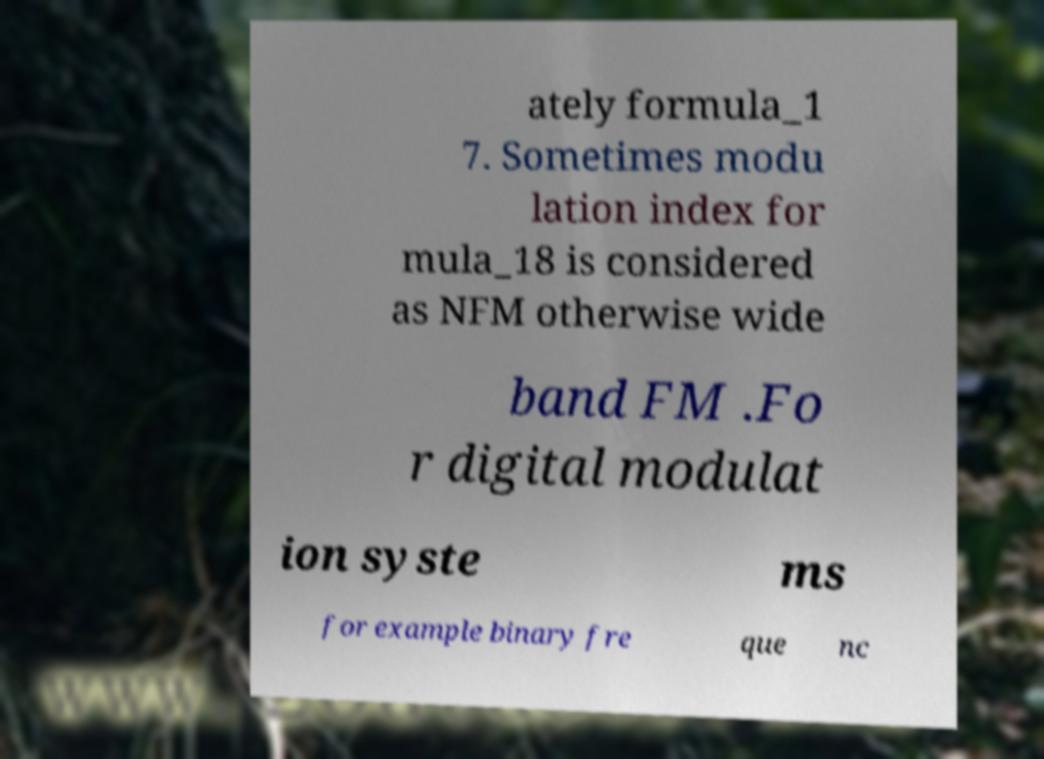Could you extract and type out the text from this image? ately formula_1 7. Sometimes modu lation index for mula_18 is considered as NFM otherwise wide band FM .Fo r digital modulat ion syste ms for example binary fre que nc 